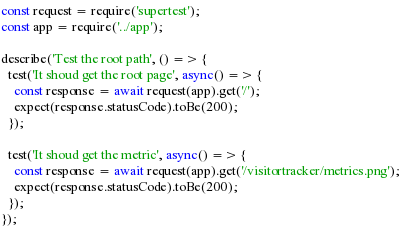Convert code to text. <code><loc_0><loc_0><loc_500><loc_500><_JavaScript_>const request = require('supertest');
const app = require('../app');

describe('Test the root path', () => {
  test('It shoud get the root page', async() => {
    const response = await request(app).get('/');
    expect(response.statusCode).toBe(200);
  });

  test('It shoud get the metric', async() => {
    const response = await request(app).get('/visitortracker/metrics.png');
    expect(response.statusCode).toBe(200);
  });
});
</code> 